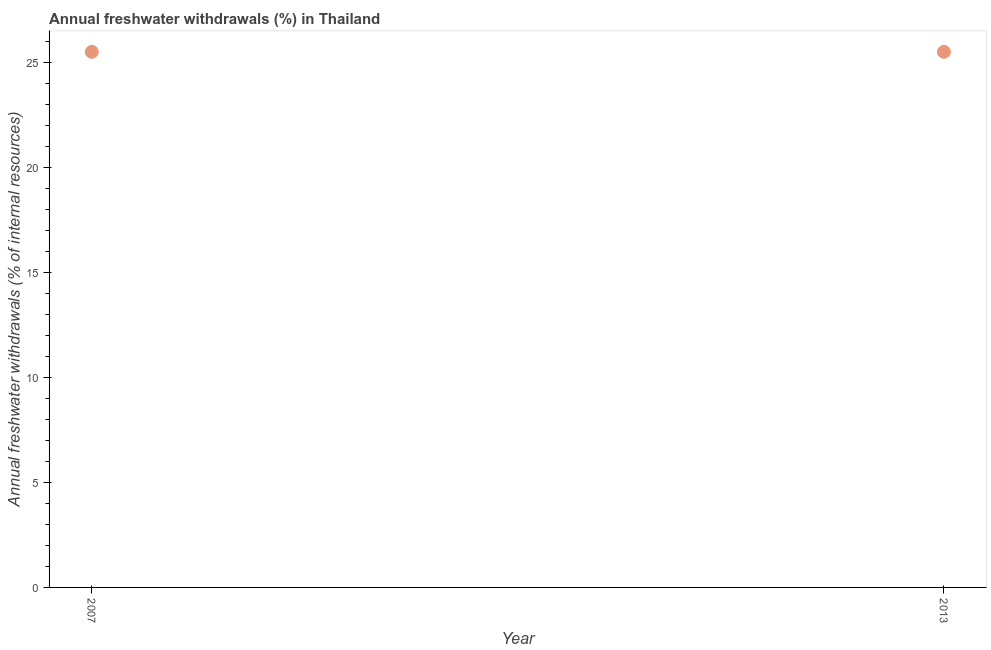What is the annual freshwater withdrawals in 2013?
Provide a short and direct response. 25.53. Across all years, what is the maximum annual freshwater withdrawals?
Give a very brief answer. 25.53. Across all years, what is the minimum annual freshwater withdrawals?
Offer a terse response. 25.53. In which year was the annual freshwater withdrawals maximum?
Provide a short and direct response. 2007. What is the sum of the annual freshwater withdrawals?
Offer a terse response. 51.06. What is the difference between the annual freshwater withdrawals in 2007 and 2013?
Your answer should be compact. 0. What is the average annual freshwater withdrawals per year?
Your answer should be compact. 25.53. What is the median annual freshwater withdrawals?
Give a very brief answer. 25.53. In how many years, is the annual freshwater withdrawals greater than 7 %?
Give a very brief answer. 2. What is the ratio of the annual freshwater withdrawals in 2007 to that in 2013?
Offer a very short reply. 1. Is the annual freshwater withdrawals in 2007 less than that in 2013?
Offer a very short reply. No. How many dotlines are there?
Your answer should be compact. 1. How many years are there in the graph?
Your answer should be very brief. 2. Are the values on the major ticks of Y-axis written in scientific E-notation?
Your answer should be very brief. No. Does the graph contain any zero values?
Offer a terse response. No. Does the graph contain grids?
Offer a very short reply. No. What is the title of the graph?
Your response must be concise. Annual freshwater withdrawals (%) in Thailand. What is the label or title of the X-axis?
Give a very brief answer. Year. What is the label or title of the Y-axis?
Make the answer very short. Annual freshwater withdrawals (% of internal resources). What is the Annual freshwater withdrawals (% of internal resources) in 2007?
Provide a succinct answer. 25.53. What is the Annual freshwater withdrawals (% of internal resources) in 2013?
Your answer should be very brief. 25.53. What is the difference between the Annual freshwater withdrawals (% of internal resources) in 2007 and 2013?
Provide a succinct answer. 0. 